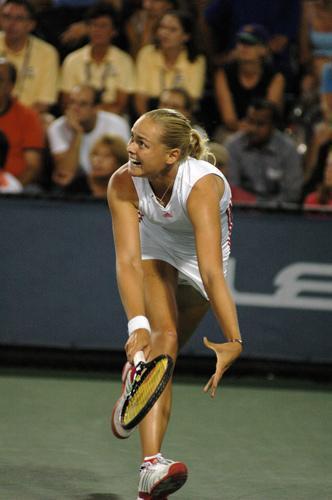What move is this female player making?
Pick the right solution, then justify: 'Answer: answer
Rationale: rationale.'
Options: Lob, serve, receive, backhand. Answer: receive.
Rationale: The move is to receive. 